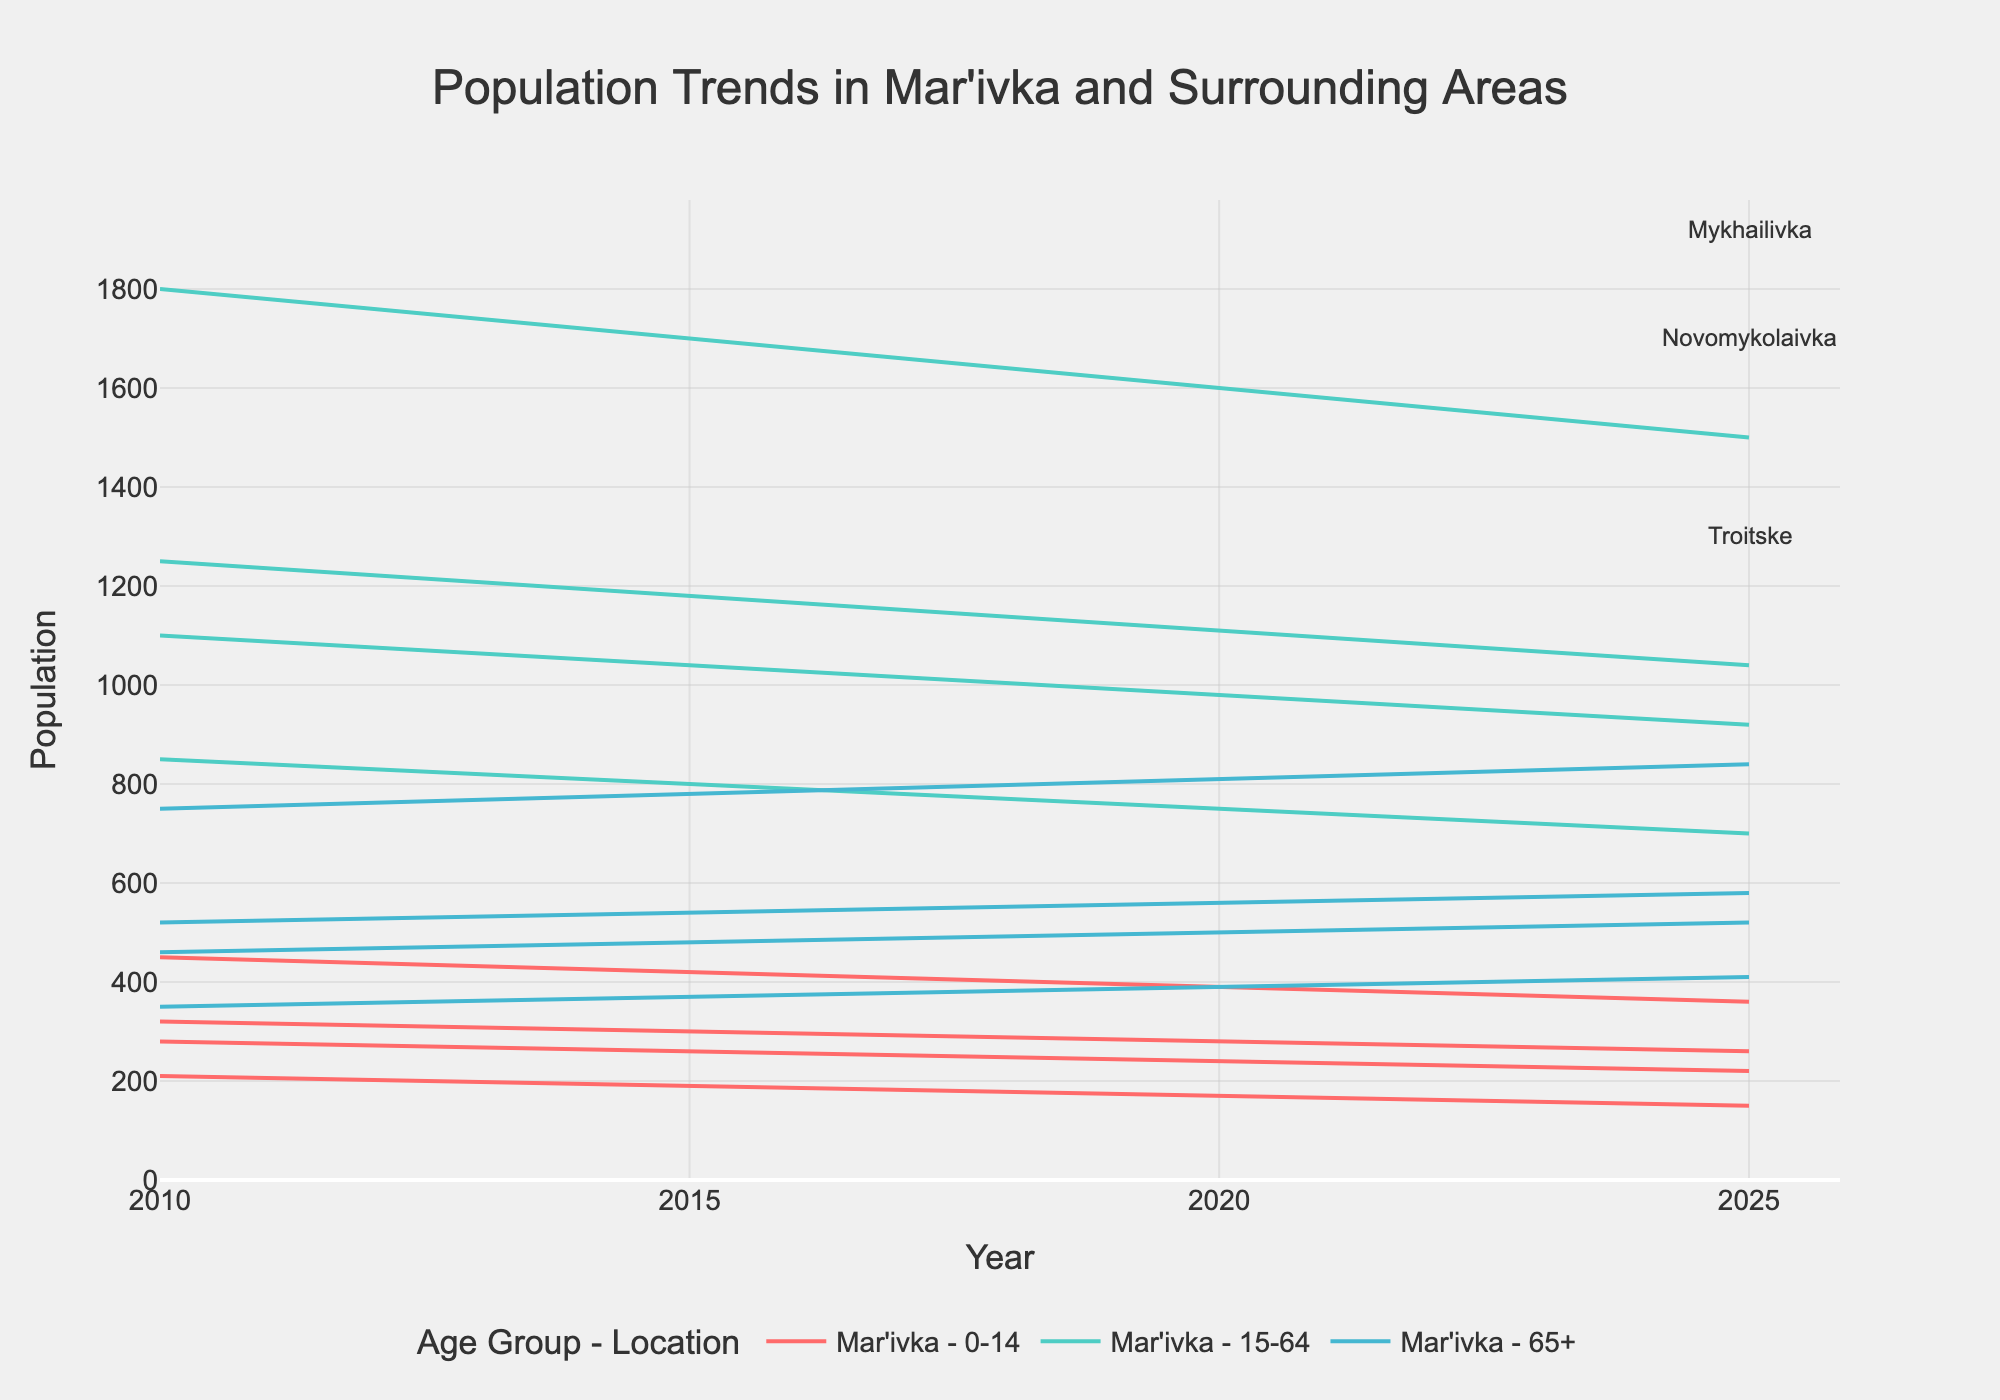What is the title of this plot? The title of the plot is typically displayed prominently at the top of the figure. It summarizes the main topic of the visual representation. In this case, the title is "Population Trends in Mar'ivka and Surrounding Areas".
Answer: Population Trends in Mar'ivka and Surrounding Areas How many age groups are represented in the data? The plot uses different colors to distinguish between age groups. There are three distinct lines for each location, correlating with age groups. These are typically listed in the legend.
Answer: 3 Which location has the highest population of 0-14-year-olds in 2010? To determine this, look at the data points for the year 2010 and find the line representing the 0-14 age group for each location. Compare their heights. The highest line for 0-14 in 2010 corresponds to Mar'ivka.
Answer: Mar'ivka What is the overall trend for the 65+ age group across all locations? Observe the lines corresponding to the 65+ age group for each location over time. Notice if these lines are moving up, down, or staying flat. All locations show an increasing trend for the 65+ age group.
Answer: Increasing How does the population of the 15-64 age group in Mykhailivka compare between 2010 and 2025? Identify the line representing the 15-64 age group for Mykhailivka at the 2010 and 2025 data points. Compare both values; one can see a decrease from 1250 to 1040.
Answer: Decrease Between which years does Mar'ivka experience the most significant decrease in population for the 0-14 age group? Examine the Mar'ivka line for the 0-14 age group and compare the slopes between consecutive years. The steepest decline is between 2015 and 2020.
Answer: 2015 and 2020 What is the difference in the population of the 15-64 age group between Mar'ivka and Troitske in 2020? Find the values for the 15-64 age group for Mar'ivka and Troitske in 2020 and subtract the smaller number from the larger one: 1600 (Mar'ivka) - 750 (Troitske) = 850.
Answer: 850 Which age group in Novomykolaivka shows the least change from 2010 to 2025? Review the lines for each age group in Novomykolaivka from 2010 to 2025. Compare the changes; the 65+ age group changes from 460 to 520, which is less drastic compared to the other groups.
Answer: 65+ 